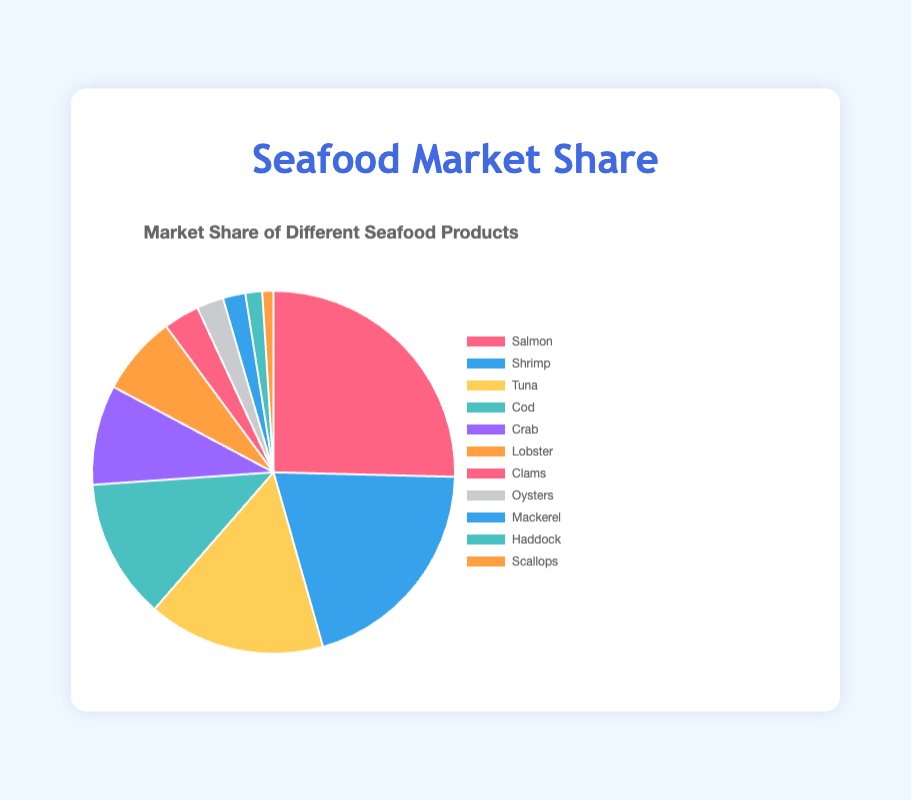What is the market share of the top three seafood products? The top three seafood products are Salmon, Shrimp, and Tuna. Their market shares are 25.4%, 20.2%, and 15.8%, respectively. Adding these, 25.4 + 20.2 + 15.8 = 61.4%.
Answer: 61.4% Which product has a higher market share, Cod or Lobster? Cod has a market share of 12.5%, while Lobster has 7.1%. Therefore, Cod has a higher market share than Lobster.
Answer: Cod What is the difference in market share between Crab and Mackerel? The market share for Crab is 8.9%, and for Mackerel, it is 2.0%. The difference is 8.9 - 2.0 = 6.9%.
Answer: 6.9% Which seafood product has the smallest market share? Scallops have the smallest market share with 1.0%.
Answer: Scallops Is the market share of Tuna greater than the combined market share of Mackerel and Haddock? The market share of Tuna is 15.8%. The combined market share of Mackerel (2.0%) and Haddock (1.5%) is 3.5%. Since 15.8% is greater than 3.5%, Tuna has a greater market share.
Answer: Yes What percentage of the market is held by Clams and Oysters combined? The market share for Clams is 3.2% and for Oysters is 2.4%. Combined, 3.2 + 2.4 = 5.6%.
Answer: 5.6% How many seafood products have a market share of less than 5%? Clams (3.2%), Oysters (2.4%), Mackerel (2.0%), Haddock (1.5%), and Scallops (1.0%) have market shares below 5%. There are 5 such products.
Answer: 5 What is the average market share of the bottom five seafood products? The bottom five products are Clams (3.2%), Oysters (2.4%), Mackerel (2.0%), Haddock (1.5%), and Scallops (1.0%). Summing these: 3.2 + 2.4 + 2.0 + 1.5 + 1.0 = 10.1%. The average is 10.1 / 5 = 2.02%.
Answer: 2.02% Among Salmon, Shrimp, and Tuna, which product has the least market share? Among these, Tuna has the least market share with 15.8%.
Answer: Tuna 